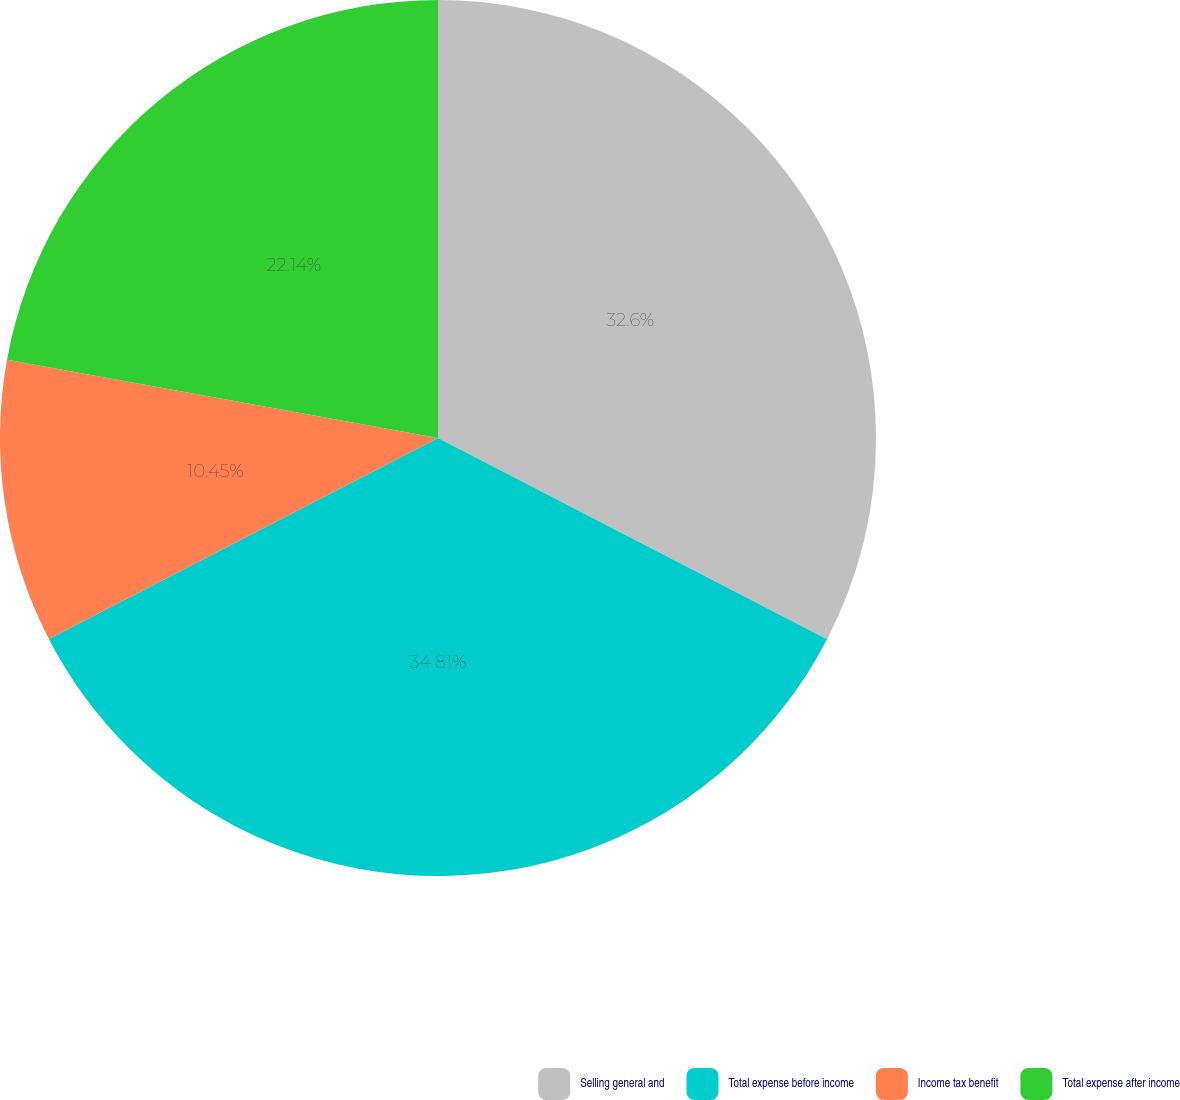Convert chart to OTSL. <chart><loc_0><loc_0><loc_500><loc_500><pie_chart><fcel>Selling general and<fcel>Total expense before income<fcel>Income tax benefit<fcel>Total expense after income<nl><fcel>32.6%<fcel>34.81%<fcel>10.45%<fcel>22.14%<nl></chart> 